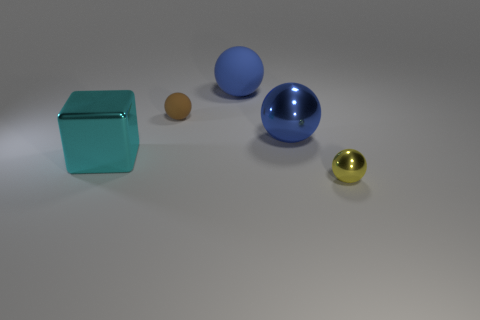Subtract all large metallic spheres. How many spheres are left? 3 Subtract all brown spheres. How many spheres are left? 3 Add 2 tiny yellow things. How many objects exist? 7 Subtract all yellow cylinders. How many blue spheres are left? 2 Subtract 1 cyan blocks. How many objects are left? 4 Subtract all spheres. How many objects are left? 1 Subtract all red blocks. Subtract all purple cylinders. How many blocks are left? 1 Subtract all large brown rubber objects. Subtract all cyan objects. How many objects are left? 4 Add 4 blue rubber spheres. How many blue rubber spheres are left? 5 Add 5 big metallic blocks. How many big metallic blocks exist? 6 